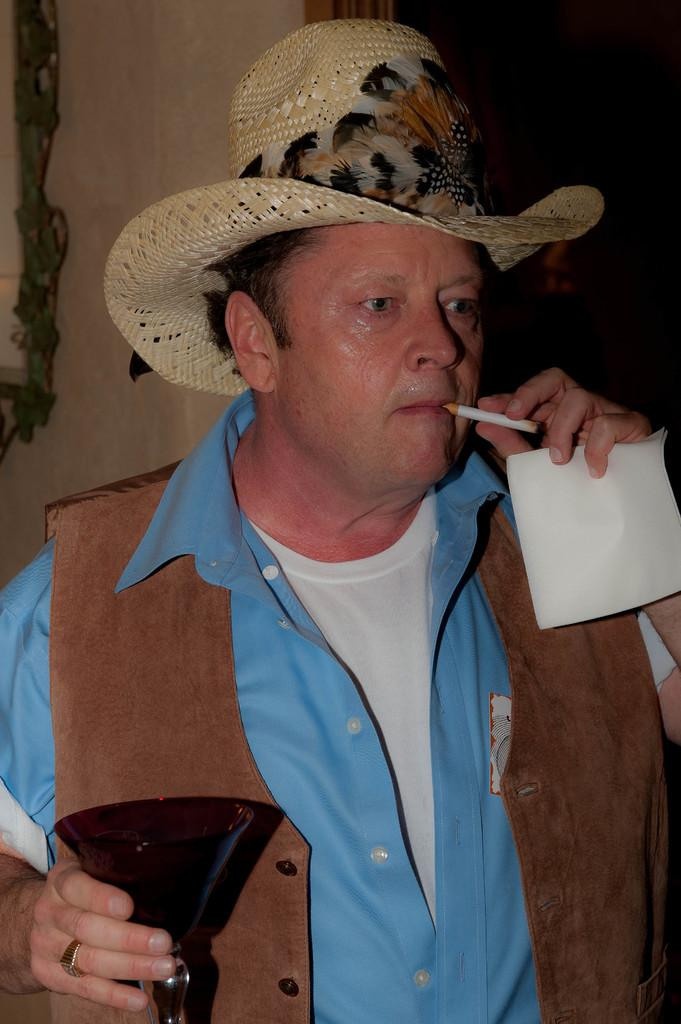What is the main subject of the image? There is a person in the image. What is the person wearing on their head? The person is wearing a hat. What objects is the person holding? The person is holding a glass, a cigarette, and tissue papers. What can be seen in the background of the image? There is a wall in the background of the image. How many sisters does the person in the image have? There is no information about the person's sisters in the image. Is there a church visible in the image? There is no church present in the image. 